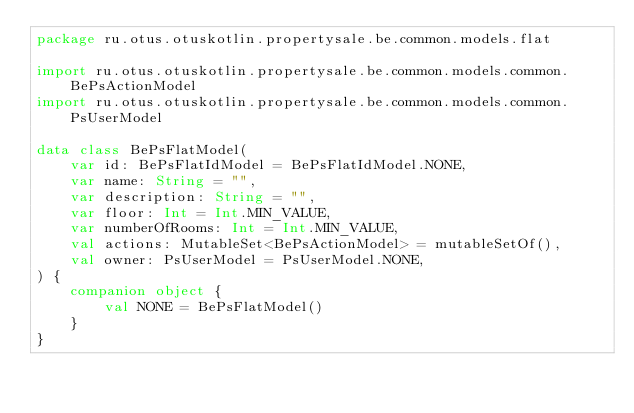<code> <loc_0><loc_0><loc_500><loc_500><_Kotlin_>package ru.otus.otuskotlin.propertysale.be.common.models.flat

import ru.otus.otuskotlin.propertysale.be.common.models.common.BePsActionModel
import ru.otus.otuskotlin.propertysale.be.common.models.common.PsUserModel

data class BePsFlatModel(
    var id: BePsFlatIdModel = BePsFlatIdModel.NONE,
    var name: String = "",
    var description: String = "",
    var floor: Int = Int.MIN_VALUE,
    var numberOfRooms: Int = Int.MIN_VALUE,
    val actions: MutableSet<BePsActionModel> = mutableSetOf(),
    val owner: PsUserModel = PsUserModel.NONE,
) {
    companion object {
        val NONE = BePsFlatModel()
    }
}
</code> 